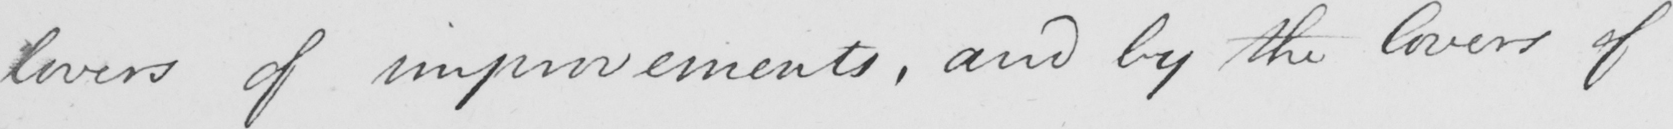Transcribe the text shown in this historical manuscript line. lovers of improvements , and by the lovers of 